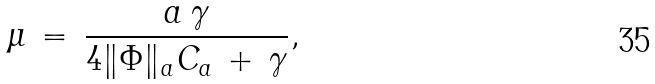<formula> <loc_0><loc_0><loc_500><loc_500>\mu \, = \, \frac { a \, \gamma } { 4 \| \Phi \| _ { a } C _ { a } \, + \, \gamma } ,</formula> 